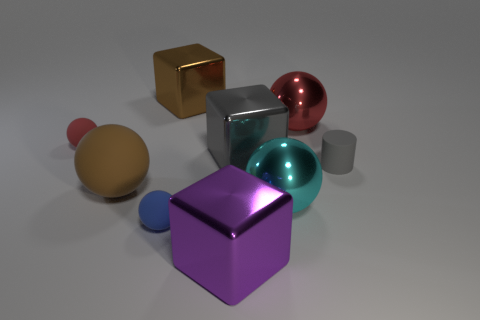Subtract 2 spheres. How many spheres are left? 3 Subtract all brown spheres. How many spheres are left? 4 Subtract all blue rubber spheres. How many spheres are left? 4 Subtract all green spheres. Subtract all gray blocks. How many spheres are left? 5 Add 1 large brown things. How many objects exist? 10 Subtract all cubes. How many objects are left? 6 Subtract all small gray matte cylinders. Subtract all small blue matte things. How many objects are left? 7 Add 7 tiny matte things. How many tiny matte things are left? 10 Add 1 tiny purple metallic blocks. How many tiny purple metallic blocks exist? 1 Subtract 0 gray spheres. How many objects are left? 9 